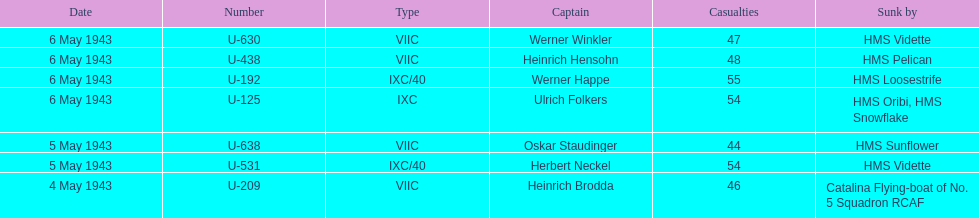Aside from oskar staudinger what was the name of the other captain of the u-boat loast on may 5? Herbert Neckel. 